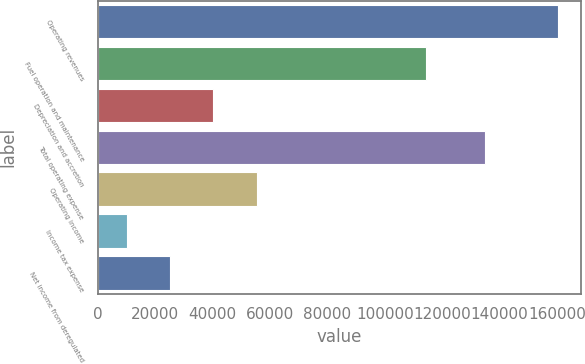<chart> <loc_0><loc_0><loc_500><loc_500><bar_chart><fcel>Operating revenues<fcel>Fuel operation and maintenance<fcel>Depreciation and accretion<fcel>Total operating expense<fcel>Operating income<fcel>Income tax expense<fcel>Net income from deregulated<nl><fcel>160478<fcel>114266<fcel>40303.6<fcel>135100<fcel>55325.4<fcel>10260<fcel>25281.8<nl></chart> 